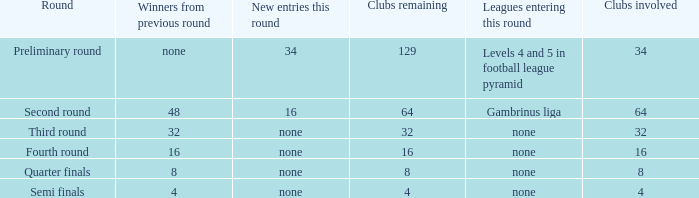Name the least clubs involved for leagues being none for semi finals 4.0. 